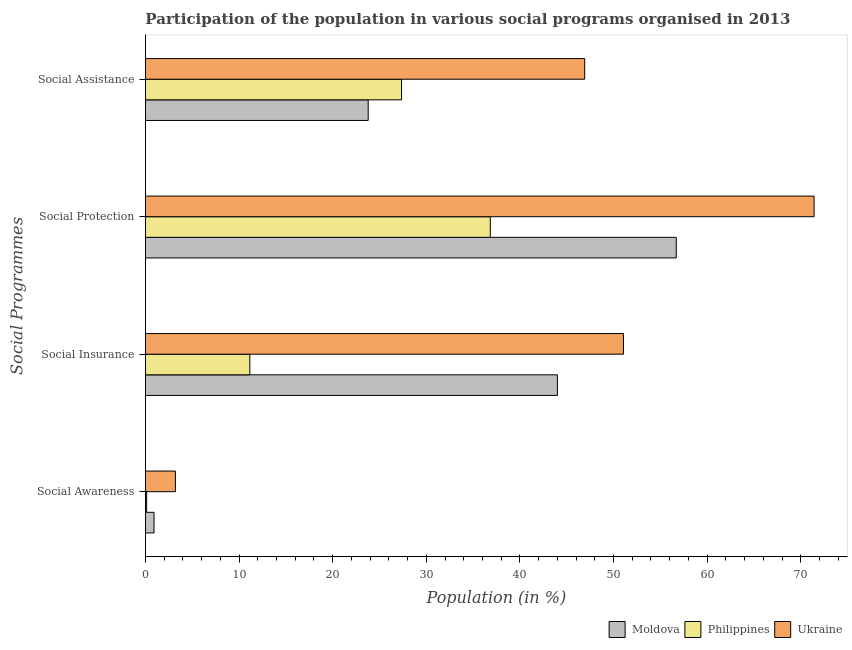How many groups of bars are there?
Give a very brief answer. 4. Are the number of bars per tick equal to the number of legend labels?
Offer a terse response. Yes. Are the number of bars on each tick of the Y-axis equal?
Provide a succinct answer. Yes. How many bars are there on the 1st tick from the top?
Your response must be concise. 3. What is the label of the 4th group of bars from the top?
Your response must be concise. Social Awareness. What is the participation of population in social protection programs in Philippines?
Provide a succinct answer. 36.84. Across all countries, what is the maximum participation of population in social awareness programs?
Provide a succinct answer. 3.2. Across all countries, what is the minimum participation of population in social awareness programs?
Ensure brevity in your answer.  0.12. In which country was the participation of population in social insurance programs maximum?
Provide a short and direct response. Ukraine. What is the total participation of population in social awareness programs in the graph?
Give a very brief answer. 4.24. What is the difference between the participation of population in social insurance programs in Moldova and that in Ukraine?
Provide a succinct answer. -7.05. What is the difference between the participation of population in social protection programs in Moldova and the participation of population in social awareness programs in Philippines?
Make the answer very short. 56.58. What is the average participation of population in social protection programs per country?
Give a very brief answer. 54.98. What is the difference between the participation of population in social insurance programs and participation of population in social assistance programs in Moldova?
Ensure brevity in your answer.  20.21. In how many countries, is the participation of population in social insurance programs greater than 18 %?
Make the answer very short. 2. What is the ratio of the participation of population in social protection programs in Philippines to that in Moldova?
Keep it short and to the point. 0.65. Is the participation of population in social insurance programs in Ukraine less than that in Philippines?
Your answer should be compact. No. What is the difference between the highest and the second highest participation of population in social awareness programs?
Make the answer very short. 2.29. What is the difference between the highest and the lowest participation of population in social insurance programs?
Offer a terse response. 39.91. What does the 3rd bar from the top in Social Insurance represents?
Your response must be concise. Moldova. What does the 1st bar from the bottom in Social Protection represents?
Provide a succinct answer. Moldova. How many bars are there?
Provide a short and direct response. 12. Are the values on the major ticks of X-axis written in scientific E-notation?
Provide a short and direct response. No. Does the graph contain any zero values?
Ensure brevity in your answer.  No. Where does the legend appear in the graph?
Give a very brief answer. Bottom right. What is the title of the graph?
Provide a succinct answer. Participation of the population in various social programs organised in 2013. What is the label or title of the X-axis?
Offer a terse response. Population (in %). What is the label or title of the Y-axis?
Offer a very short reply. Social Programmes. What is the Population (in %) in Moldova in Social Awareness?
Offer a very short reply. 0.92. What is the Population (in %) in Philippines in Social Awareness?
Your answer should be compact. 0.12. What is the Population (in %) in Ukraine in Social Awareness?
Offer a terse response. 3.2. What is the Population (in %) in Moldova in Social Insurance?
Offer a terse response. 44.01. What is the Population (in %) in Philippines in Social Insurance?
Provide a short and direct response. 11.15. What is the Population (in %) of Ukraine in Social Insurance?
Provide a short and direct response. 51.06. What is the Population (in %) of Moldova in Social Protection?
Ensure brevity in your answer.  56.7. What is the Population (in %) of Philippines in Social Protection?
Your answer should be very brief. 36.84. What is the Population (in %) in Ukraine in Social Protection?
Keep it short and to the point. 71.42. What is the Population (in %) of Moldova in Social Assistance?
Provide a short and direct response. 23.79. What is the Population (in %) in Philippines in Social Assistance?
Keep it short and to the point. 27.35. What is the Population (in %) of Ukraine in Social Assistance?
Your answer should be very brief. 46.92. Across all Social Programmes, what is the maximum Population (in %) of Moldova?
Provide a succinct answer. 56.7. Across all Social Programmes, what is the maximum Population (in %) of Philippines?
Give a very brief answer. 36.84. Across all Social Programmes, what is the maximum Population (in %) in Ukraine?
Offer a very short reply. 71.42. Across all Social Programmes, what is the minimum Population (in %) in Moldova?
Your answer should be compact. 0.92. Across all Social Programmes, what is the minimum Population (in %) in Philippines?
Offer a terse response. 0.12. Across all Social Programmes, what is the minimum Population (in %) in Ukraine?
Your answer should be compact. 3.2. What is the total Population (in %) of Moldova in the graph?
Provide a short and direct response. 125.41. What is the total Population (in %) in Philippines in the graph?
Your response must be concise. 75.46. What is the total Population (in %) of Ukraine in the graph?
Give a very brief answer. 172.6. What is the difference between the Population (in %) of Moldova in Social Awareness and that in Social Insurance?
Provide a short and direct response. -43.09. What is the difference between the Population (in %) of Philippines in Social Awareness and that in Social Insurance?
Give a very brief answer. -11.02. What is the difference between the Population (in %) of Ukraine in Social Awareness and that in Social Insurance?
Offer a terse response. -47.86. What is the difference between the Population (in %) of Moldova in Social Awareness and that in Social Protection?
Provide a succinct answer. -55.78. What is the difference between the Population (in %) of Philippines in Social Awareness and that in Social Protection?
Your response must be concise. -36.71. What is the difference between the Population (in %) in Ukraine in Social Awareness and that in Social Protection?
Provide a succinct answer. -68.22. What is the difference between the Population (in %) in Moldova in Social Awareness and that in Social Assistance?
Provide a succinct answer. -22.88. What is the difference between the Population (in %) in Philippines in Social Awareness and that in Social Assistance?
Your answer should be very brief. -27.23. What is the difference between the Population (in %) in Ukraine in Social Awareness and that in Social Assistance?
Provide a succinct answer. -43.72. What is the difference between the Population (in %) of Moldova in Social Insurance and that in Social Protection?
Your response must be concise. -12.69. What is the difference between the Population (in %) of Philippines in Social Insurance and that in Social Protection?
Keep it short and to the point. -25.69. What is the difference between the Population (in %) in Ukraine in Social Insurance and that in Social Protection?
Your response must be concise. -20.36. What is the difference between the Population (in %) in Moldova in Social Insurance and that in Social Assistance?
Provide a succinct answer. 20.21. What is the difference between the Population (in %) of Philippines in Social Insurance and that in Social Assistance?
Offer a terse response. -16.21. What is the difference between the Population (in %) in Ukraine in Social Insurance and that in Social Assistance?
Give a very brief answer. 4.14. What is the difference between the Population (in %) in Moldova in Social Protection and that in Social Assistance?
Keep it short and to the point. 32.91. What is the difference between the Population (in %) of Philippines in Social Protection and that in Social Assistance?
Ensure brevity in your answer.  9.48. What is the difference between the Population (in %) of Ukraine in Social Protection and that in Social Assistance?
Make the answer very short. 24.5. What is the difference between the Population (in %) of Moldova in Social Awareness and the Population (in %) of Philippines in Social Insurance?
Provide a succinct answer. -10.23. What is the difference between the Population (in %) in Moldova in Social Awareness and the Population (in %) in Ukraine in Social Insurance?
Ensure brevity in your answer.  -50.14. What is the difference between the Population (in %) of Philippines in Social Awareness and the Population (in %) of Ukraine in Social Insurance?
Provide a short and direct response. -50.94. What is the difference between the Population (in %) in Moldova in Social Awareness and the Population (in %) in Philippines in Social Protection?
Keep it short and to the point. -35.92. What is the difference between the Population (in %) of Moldova in Social Awareness and the Population (in %) of Ukraine in Social Protection?
Make the answer very short. -70.5. What is the difference between the Population (in %) of Philippines in Social Awareness and the Population (in %) of Ukraine in Social Protection?
Give a very brief answer. -71.3. What is the difference between the Population (in %) in Moldova in Social Awareness and the Population (in %) in Philippines in Social Assistance?
Make the answer very short. -26.44. What is the difference between the Population (in %) of Moldova in Social Awareness and the Population (in %) of Ukraine in Social Assistance?
Ensure brevity in your answer.  -46. What is the difference between the Population (in %) in Philippines in Social Awareness and the Population (in %) in Ukraine in Social Assistance?
Make the answer very short. -46.79. What is the difference between the Population (in %) of Moldova in Social Insurance and the Population (in %) of Philippines in Social Protection?
Keep it short and to the point. 7.17. What is the difference between the Population (in %) of Moldova in Social Insurance and the Population (in %) of Ukraine in Social Protection?
Provide a succinct answer. -27.41. What is the difference between the Population (in %) in Philippines in Social Insurance and the Population (in %) in Ukraine in Social Protection?
Ensure brevity in your answer.  -60.27. What is the difference between the Population (in %) in Moldova in Social Insurance and the Population (in %) in Philippines in Social Assistance?
Ensure brevity in your answer.  16.65. What is the difference between the Population (in %) in Moldova in Social Insurance and the Population (in %) in Ukraine in Social Assistance?
Make the answer very short. -2.91. What is the difference between the Population (in %) in Philippines in Social Insurance and the Population (in %) in Ukraine in Social Assistance?
Offer a terse response. -35.77. What is the difference between the Population (in %) of Moldova in Social Protection and the Population (in %) of Philippines in Social Assistance?
Provide a succinct answer. 29.34. What is the difference between the Population (in %) in Moldova in Social Protection and the Population (in %) in Ukraine in Social Assistance?
Provide a succinct answer. 9.78. What is the difference between the Population (in %) of Philippines in Social Protection and the Population (in %) of Ukraine in Social Assistance?
Make the answer very short. -10.08. What is the average Population (in %) in Moldova per Social Programmes?
Your answer should be very brief. 31.35. What is the average Population (in %) in Philippines per Social Programmes?
Your response must be concise. 18.86. What is the average Population (in %) of Ukraine per Social Programmes?
Offer a terse response. 43.15. What is the difference between the Population (in %) of Moldova and Population (in %) of Philippines in Social Awareness?
Offer a very short reply. 0.79. What is the difference between the Population (in %) in Moldova and Population (in %) in Ukraine in Social Awareness?
Offer a terse response. -2.29. What is the difference between the Population (in %) in Philippines and Population (in %) in Ukraine in Social Awareness?
Give a very brief answer. -3.08. What is the difference between the Population (in %) in Moldova and Population (in %) in Philippines in Social Insurance?
Offer a very short reply. 32.86. What is the difference between the Population (in %) of Moldova and Population (in %) of Ukraine in Social Insurance?
Make the answer very short. -7.05. What is the difference between the Population (in %) of Philippines and Population (in %) of Ukraine in Social Insurance?
Give a very brief answer. -39.91. What is the difference between the Population (in %) in Moldova and Population (in %) in Philippines in Social Protection?
Your response must be concise. 19.86. What is the difference between the Population (in %) in Moldova and Population (in %) in Ukraine in Social Protection?
Offer a terse response. -14.72. What is the difference between the Population (in %) in Philippines and Population (in %) in Ukraine in Social Protection?
Ensure brevity in your answer.  -34.58. What is the difference between the Population (in %) in Moldova and Population (in %) in Philippines in Social Assistance?
Offer a very short reply. -3.56. What is the difference between the Population (in %) in Moldova and Population (in %) in Ukraine in Social Assistance?
Your answer should be compact. -23.13. What is the difference between the Population (in %) in Philippines and Population (in %) in Ukraine in Social Assistance?
Keep it short and to the point. -19.56. What is the ratio of the Population (in %) in Moldova in Social Awareness to that in Social Insurance?
Give a very brief answer. 0.02. What is the ratio of the Population (in %) in Philippines in Social Awareness to that in Social Insurance?
Ensure brevity in your answer.  0.01. What is the ratio of the Population (in %) in Ukraine in Social Awareness to that in Social Insurance?
Offer a terse response. 0.06. What is the ratio of the Population (in %) in Moldova in Social Awareness to that in Social Protection?
Offer a very short reply. 0.02. What is the ratio of the Population (in %) in Philippines in Social Awareness to that in Social Protection?
Your response must be concise. 0. What is the ratio of the Population (in %) of Ukraine in Social Awareness to that in Social Protection?
Ensure brevity in your answer.  0.04. What is the ratio of the Population (in %) of Moldova in Social Awareness to that in Social Assistance?
Give a very brief answer. 0.04. What is the ratio of the Population (in %) in Philippines in Social Awareness to that in Social Assistance?
Provide a short and direct response. 0. What is the ratio of the Population (in %) in Ukraine in Social Awareness to that in Social Assistance?
Ensure brevity in your answer.  0.07. What is the ratio of the Population (in %) of Moldova in Social Insurance to that in Social Protection?
Provide a succinct answer. 0.78. What is the ratio of the Population (in %) of Philippines in Social Insurance to that in Social Protection?
Keep it short and to the point. 0.3. What is the ratio of the Population (in %) of Ukraine in Social Insurance to that in Social Protection?
Offer a terse response. 0.71. What is the ratio of the Population (in %) of Moldova in Social Insurance to that in Social Assistance?
Ensure brevity in your answer.  1.85. What is the ratio of the Population (in %) in Philippines in Social Insurance to that in Social Assistance?
Your response must be concise. 0.41. What is the ratio of the Population (in %) in Ukraine in Social Insurance to that in Social Assistance?
Make the answer very short. 1.09. What is the ratio of the Population (in %) in Moldova in Social Protection to that in Social Assistance?
Provide a short and direct response. 2.38. What is the ratio of the Population (in %) of Philippines in Social Protection to that in Social Assistance?
Ensure brevity in your answer.  1.35. What is the ratio of the Population (in %) of Ukraine in Social Protection to that in Social Assistance?
Offer a very short reply. 1.52. What is the difference between the highest and the second highest Population (in %) of Moldova?
Ensure brevity in your answer.  12.69. What is the difference between the highest and the second highest Population (in %) in Philippines?
Your response must be concise. 9.48. What is the difference between the highest and the second highest Population (in %) of Ukraine?
Your answer should be very brief. 20.36. What is the difference between the highest and the lowest Population (in %) in Moldova?
Offer a very short reply. 55.78. What is the difference between the highest and the lowest Population (in %) in Philippines?
Your response must be concise. 36.71. What is the difference between the highest and the lowest Population (in %) of Ukraine?
Offer a very short reply. 68.22. 